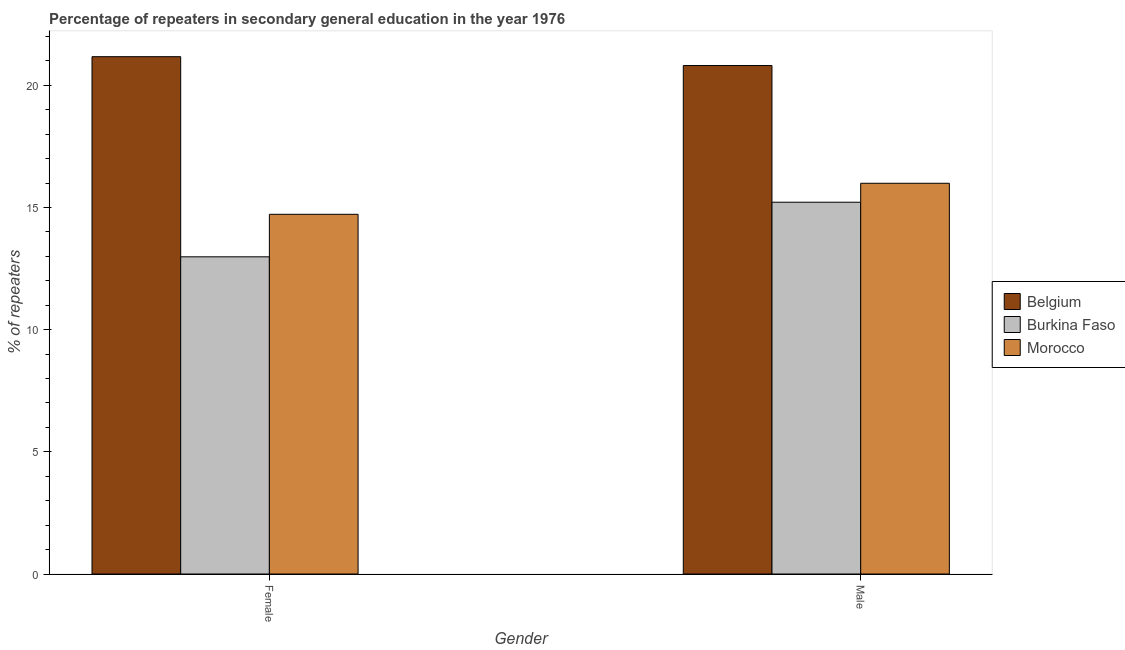How many different coloured bars are there?
Offer a terse response. 3. Are the number of bars per tick equal to the number of legend labels?
Offer a very short reply. Yes. Are the number of bars on each tick of the X-axis equal?
Keep it short and to the point. Yes. How many bars are there on the 1st tick from the left?
Offer a very short reply. 3. How many bars are there on the 1st tick from the right?
Provide a succinct answer. 3. What is the label of the 1st group of bars from the left?
Ensure brevity in your answer.  Female. What is the percentage of male repeaters in Burkina Faso?
Provide a short and direct response. 15.21. Across all countries, what is the maximum percentage of female repeaters?
Provide a succinct answer. 21.17. Across all countries, what is the minimum percentage of male repeaters?
Offer a very short reply. 15.21. In which country was the percentage of male repeaters minimum?
Make the answer very short. Burkina Faso. What is the total percentage of male repeaters in the graph?
Offer a very short reply. 52.01. What is the difference between the percentage of male repeaters in Belgium and that in Morocco?
Your response must be concise. 4.82. What is the difference between the percentage of female repeaters in Belgium and the percentage of male repeaters in Morocco?
Your response must be concise. 5.18. What is the average percentage of female repeaters per country?
Offer a very short reply. 16.29. What is the difference between the percentage of male repeaters and percentage of female repeaters in Belgium?
Make the answer very short. -0.36. In how many countries, is the percentage of female repeaters greater than 21 %?
Give a very brief answer. 1. What is the ratio of the percentage of male repeaters in Burkina Faso to that in Morocco?
Your response must be concise. 0.95. In how many countries, is the percentage of male repeaters greater than the average percentage of male repeaters taken over all countries?
Your answer should be very brief. 1. What does the 2nd bar from the left in Male represents?
Keep it short and to the point. Burkina Faso. Are all the bars in the graph horizontal?
Ensure brevity in your answer.  No. How many countries are there in the graph?
Keep it short and to the point. 3. Are the values on the major ticks of Y-axis written in scientific E-notation?
Your response must be concise. No. How are the legend labels stacked?
Provide a short and direct response. Vertical. What is the title of the graph?
Keep it short and to the point. Percentage of repeaters in secondary general education in the year 1976. What is the label or title of the X-axis?
Offer a terse response. Gender. What is the label or title of the Y-axis?
Your response must be concise. % of repeaters. What is the % of repeaters in Belgium in Female?
Your answer should be compact. 21.17. What is the % of repeaters of Burkina Faso in Female?
Your response must be concise. 12.98. What is the % of repeaters in Morocco in Female?
Your answer should be very brief. 14.72. What is the % of repeaters in Belgium in Male?
Your answer should be compact. 20.81. What is the % of repeaters of Burkina Faso in Male?
Provide a short and direct response. 15.21. What is the % of repeaters in Morocco in Male?
Your answer should be compact. 15.99. Across all Gender, what is the maximum % of repeaters of Belgium?
Offer a terse response. 21.17. Across all Gender, what is the maximum % of repeaters of Burkina Faso?
Your answer should be very brief. 15.21. Across all Gender, what is the maximum % of repeaters of Morocco?
Provide a short and direct response. 15.99. Across all Gender, what is the minimum % of repeaters of Belgium?
Make the answer very short. 20.81. Across all Gender, what is the minimum % of repeaters in Burkina Faso?
Your response must be concise. 12.98. Across all Gender, what is the minimum % of repeaters of Morocco?
Offer a very short reply. 14.72. What is the total % of repeaters in Belgium in the graph?
Your answer should be very brief. 41.98. What is the total % of repeaters of Burkina Faso in the graph?
Provide a succinct answer. 28.19. What is the total % of repeaters of Morocco in the graph?
Ensure brevity in your answer.  30.71. What is the difference between the % of repeaters of Belgium in Female and that in Male?
Keep it short and to the point. 0.36. What is the difference between the % of repeaters of Burkina Faso in Female and that in Male?
Provide a succinct answer. -2.23. What is the difference between the % of repeaters in Morocco in Female and that in Male?
Provide a succinct answer. -1.27. What is the difference between the % of repeaters in Belgium in Female and the % of repeaters in Burkina Faso in Male?
Provide a succinct answer. 5.96. What is the difference between the % of repeaters in Belgium in Female and the % of repeaters in Morocco in Male?
Make the answer very short. 5.18. What is the difference between the % of repeaters in Burkina Faso in Female and the % of repeaters in Morocco in Male?
Your answer should be very brief. -3.01. What is the average % of repeaters in Belgium per Gender?
Your answer should be compact. 20.99. What is the average % of repeaters in Burkina Faso per Gender?
Make the answer very short. 14.1. What is the average % of repeaters of Morocco per Gender?
Provide a short and direct response. 15.35. What is the difference between the % of repeaters in Belgium and % of repeaters in Burkina Faso in Female?
Make the answer very short. 8.19. What is the difference between the % of repeaters in Belgium and % of repeaters in Morocco in Female?
Offer a terse response. 6.45. What is the difference between the % of repeaters of Burkina Faso and % of repeaters of Morocco in Female?
Your answer should be compact. -1.74. What is the difference between the % of repeaters of Belgium and % of repeaters of Burkina Faso in Male?
Provide a short and direct response. 5.59. What is the difference between the % of repeaters in Belgium and % of repeaters in Morocco in Male?
Give a very brief answer. 4.82. What is the difference between the % of repeaters in Burkina Faso and % of repeaters in Morocco in Male?
Your response must be concise. -0.78. What is the ratio of the % of repeaters of Belgium in Female to that in Male?
Offer a terse response. 1.02. What is the ratio of the % of repeaters of Burkina Faso in Female to that in Male?
Make the answer very short. 0.85. What is the ratio of the % of repeaters in Morocco in Female to that in Male?
Offer a very short reply. 0.92. What is the difference between the highest and the second highest % of repeaters of Belgium?
Your answer should be very brief. 0.36. What is the difference between the highest and the second highest % of repeaters in Burkina Faso?
Ensure brevity in your answer.  2.23. What is the difference between the highest and the second highest % of repeaters in Morocco?
Your answer should be very brief. 1.27. What is the difference between the highest and the lowest % of repeaters of Belgium?
Offer a terse response. 0.36. What is the difference between the highest and the lowest % of repeaters in Burkina Faso?
Provide a short and direct response. 2.23. What is the difference between the highest and the lowest % of repeaters in Morocco?
Keep it short and to the point. 1.27. 